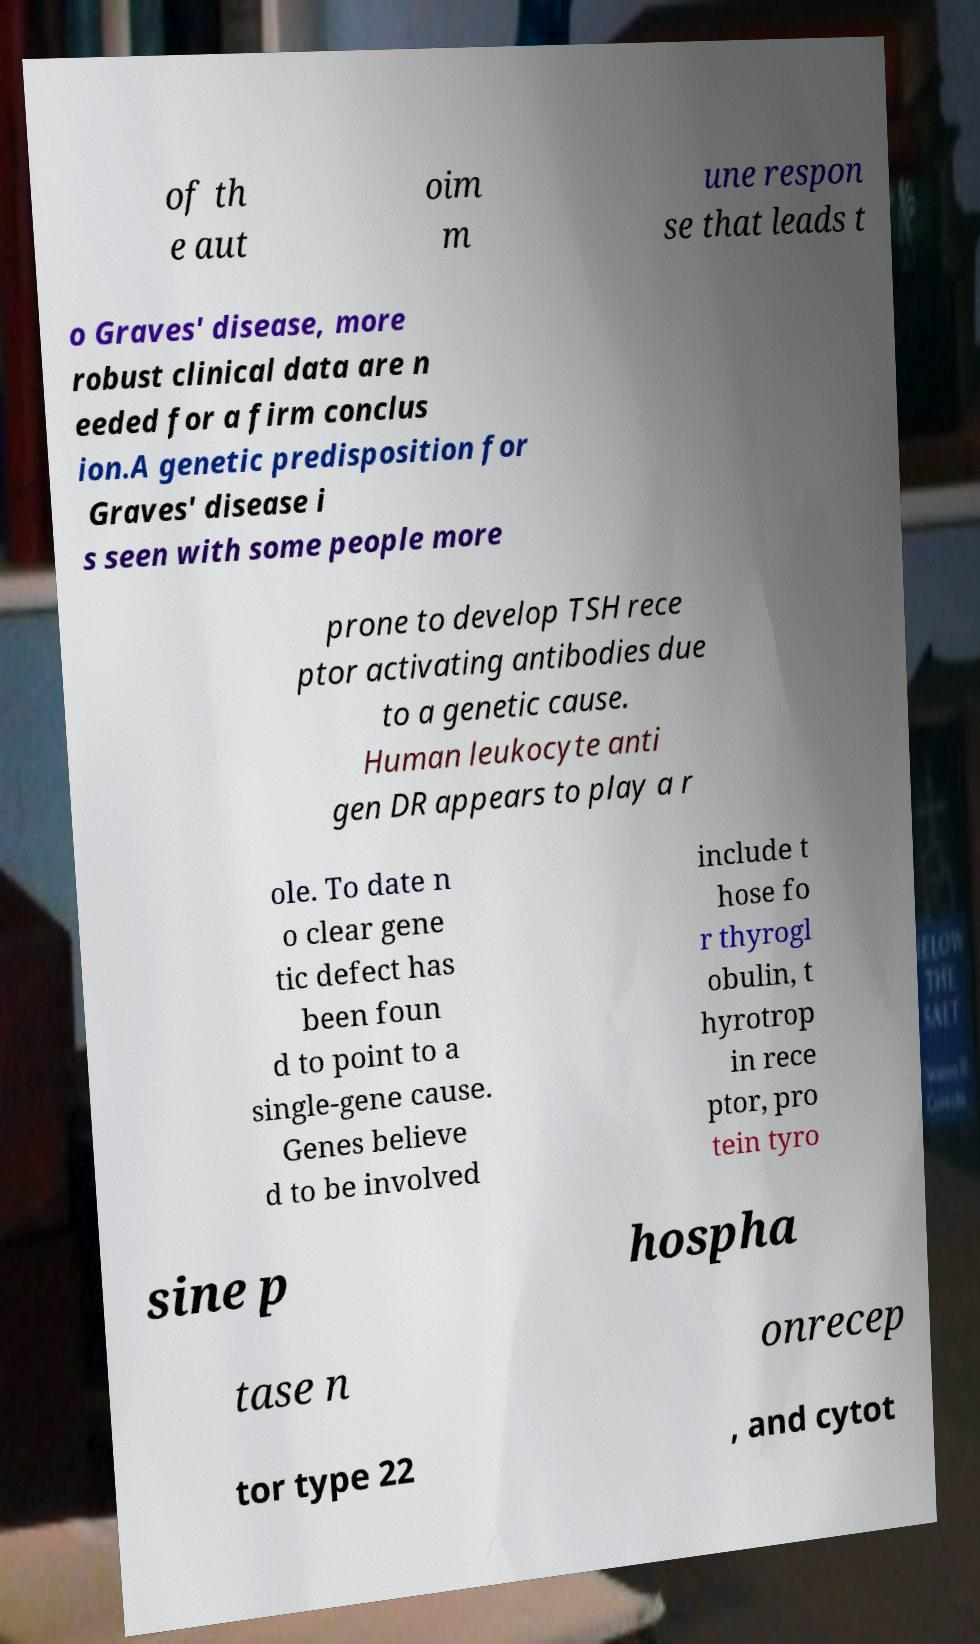Please read and relay the text visible in this image. What does it say? of th e aut oim m une respon se that leads t o Graves' disease, more robust clinical data are n eeded for a firm conclus ion.A genetic predisposition for Graves' disease i s seen with some people more prone to develop TSH rece ptor activating antibodies due to a genetic cause. Human leukocyte anti gen DR appears to play a r ole. To date n o clear gene tic defect has been foun d to point to a single-gene cause. Genes believe d to be involved include t hose fo r thyrogl obulin, t hyrotrop in rece ptor, pro tein tyro sine p hospha tase n onrecep tor type 22 , and cytot 